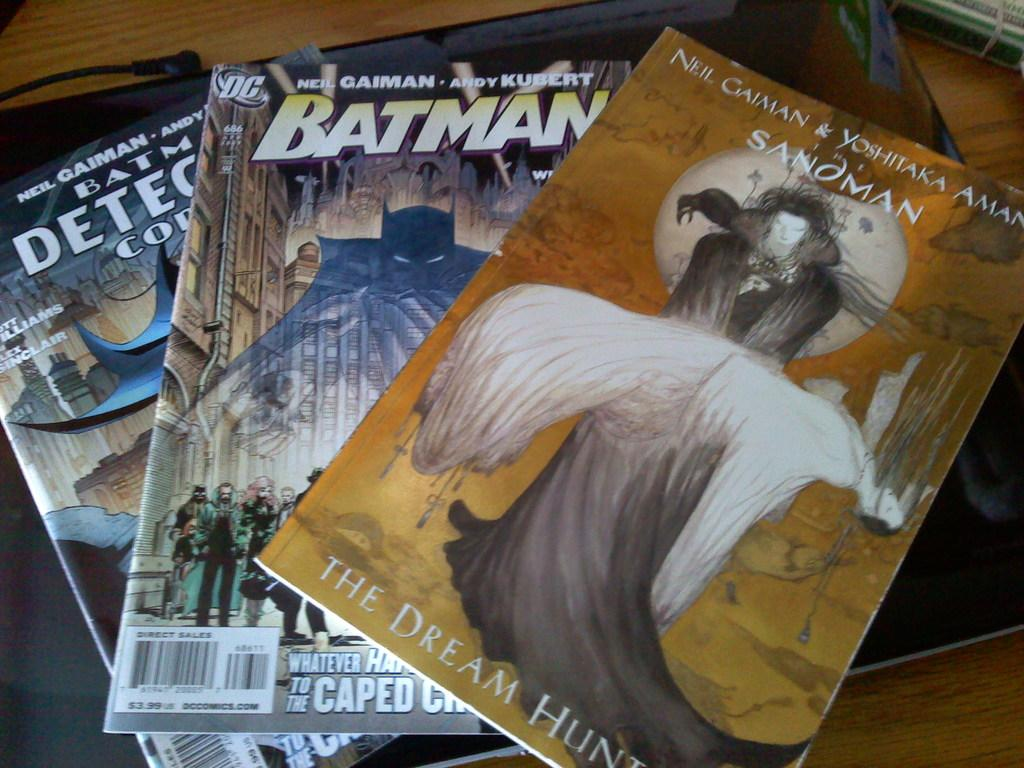How many books are visible in the image? There are three books in the image. What can be seen on the books? There is writing on the books. What is the color scheme of the books? The books are in different colors. Where are the books located in the image? The books are on a brown table. Are there any masks visible on the books in the image? No, there are no masks present on the books in the image. 